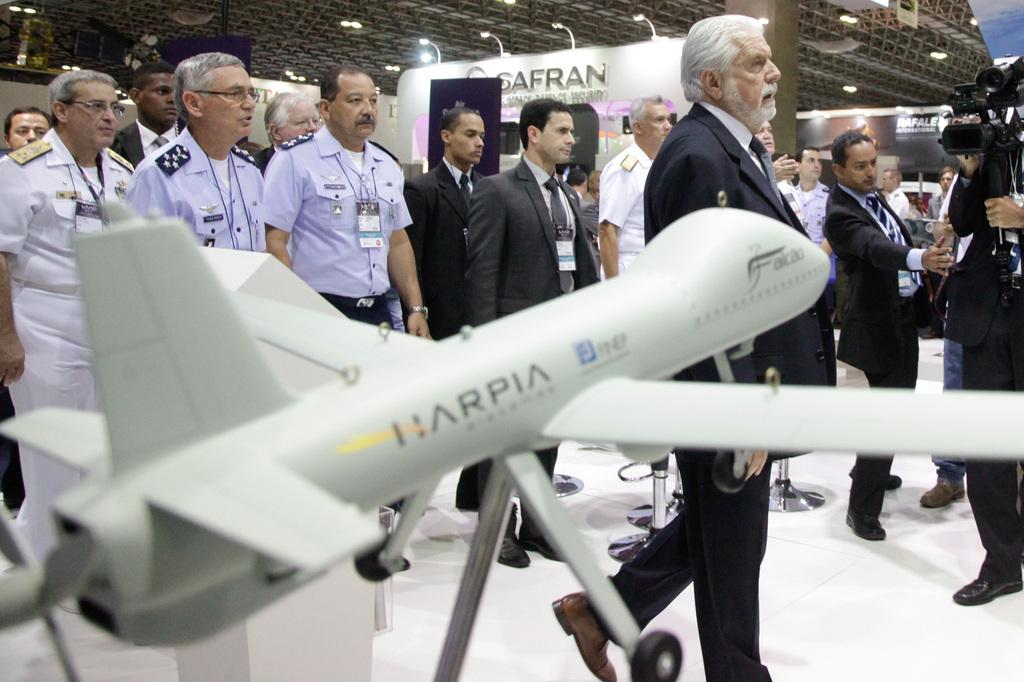How many people are present in the image? There are many people in the image. What can be observed about some of the people in the image? Some people are wearing tags. What type of object can be seen in the image? There is a model of an aircraft in the image. What can be seen in the background of the image? There are banners in the background of the image. What type of illumination is present in the image? There are lights in the image. What type of owl can be seen sitting on the model of the aircraft in the image? There is no owl present in the image, let alone one sitting on the model of the aircraft. What type of treatment is being administered to the goat in the image? There is no goat present in the image, so no treatment can be observed. 